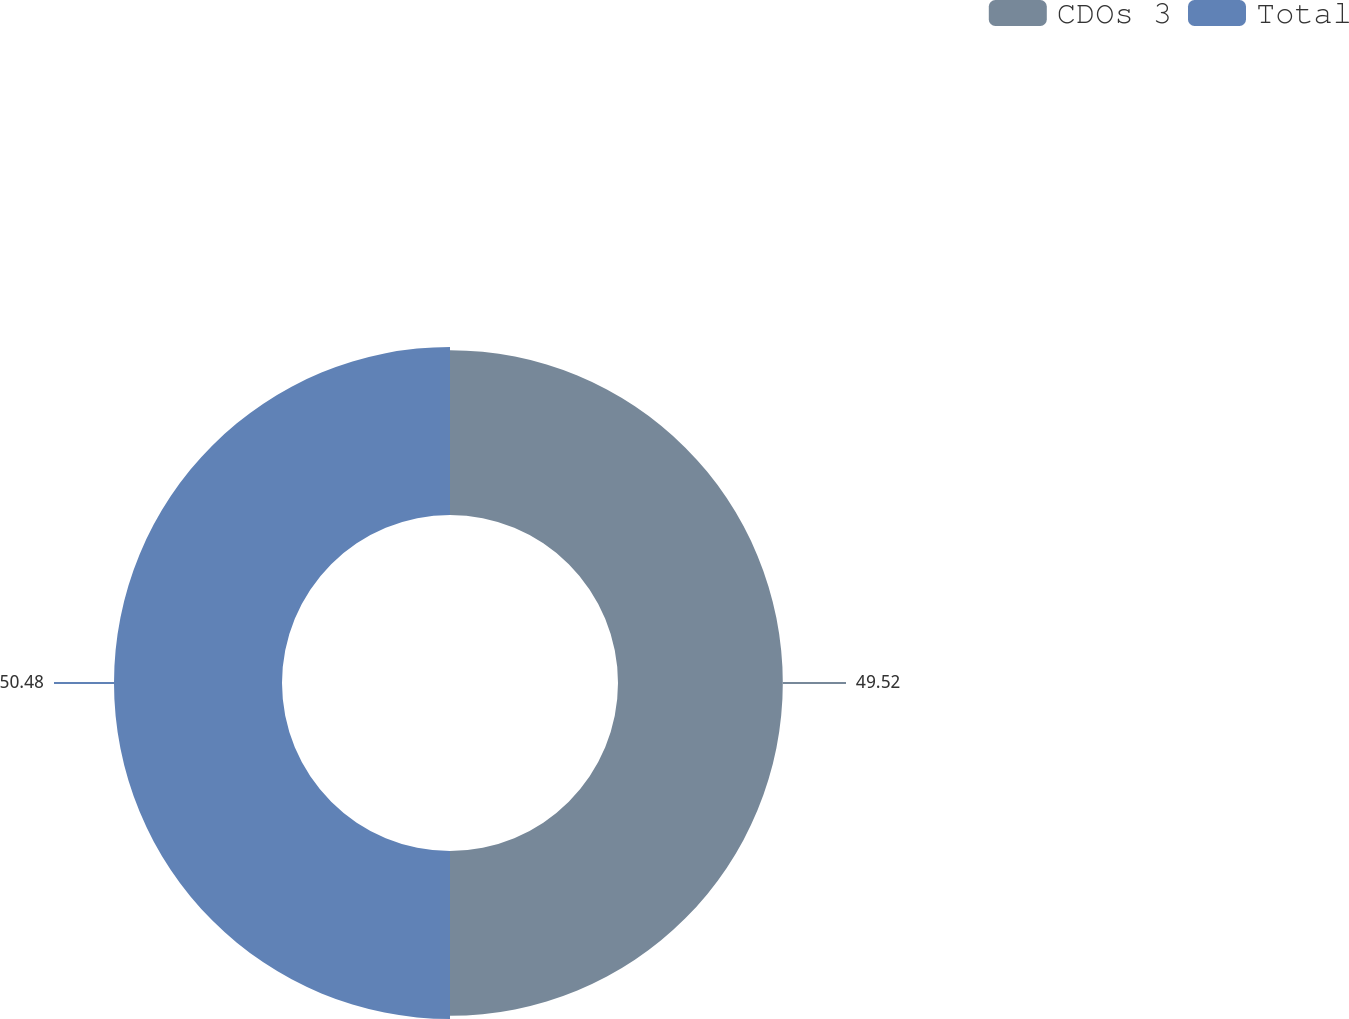<chart> <loc_0><loc_0><loc_500><loc_500><pie_chart><fcel>CDOs 3<fcel>Total<nl><fcel>49.52%<fcel>50.48%<nl></chart> 